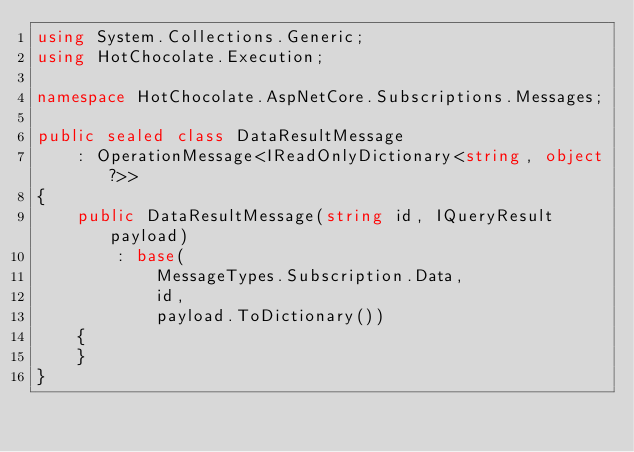Convert code to text. <code><loc_0><loc_0><loc_500><loc_500><_C#_>using System.Collections.Generic;
using HotChocolate.Execution;

namespace HotChocolate.AspNetCore.Subscriptions.Messages;

public sealed class DataResultMessage
    : OperationMessage<IReadOnlyDictionary<string, object?>>
{
    public DataResultMessage(string id, IQueryResult payload)
        : base(
            MessageTypes.Subscription.Data,
            id,
            payload.ToDictionary())
    {
    }
}
</code> 